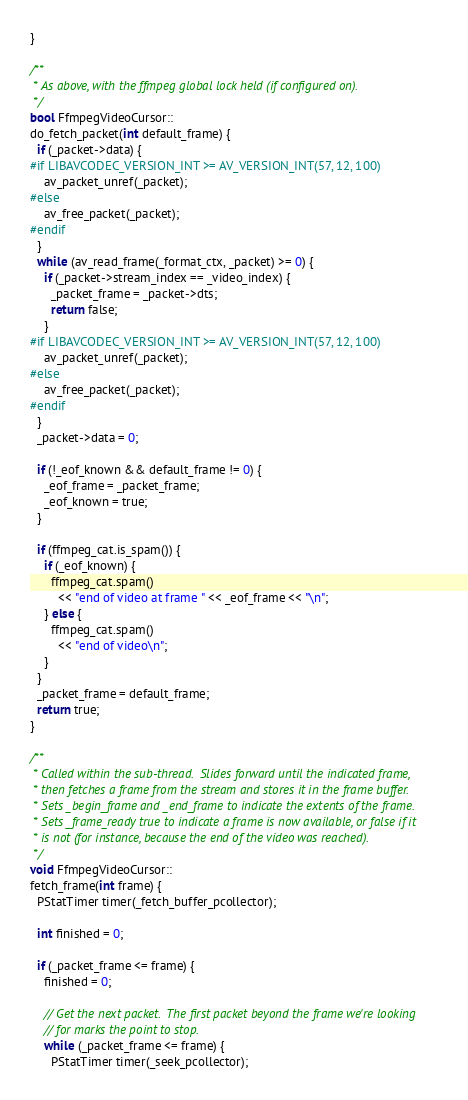Convert code to text. <code><loc_0><loc_0><loc_500><loc_500><_C++_>}

/**
 * As above, with the ffmpeg global lock held (if configured on).
 */
bool FfmpegVideoCursor::
do_fetch_packet(int default_frame) {
  if (_packet->data) {
#if LIBAVCODEC_VERSION_INT >= AV_VERSION_INT(57, 12, 100)
    av_packet_unref(_packet);
#else
    av_free_packet(_packet);
#endif
  }
  while (av_read_frame(_format_ctx, _packet) >= 0) {
    if (_packet->stream_index == _video_index) {
      _packet_frame = _packet->dts;
      return false;
    }
#if LIBAVCODEC_VERSION_INT >= AV_VERSION_INT(57, 12, 100)
    av_packet_unref(_packet);
#else
    av_free_packet(_packet);
#endif
  }
  _packet->data = 0;

  if (!_eof_known && default_frame != 0) {
    _eof_frame = _packet_frame;
    _eof_known = true;
  }

  if (ffmpeg_cat.is_spam()) {
    if (_eof_known) {
      ffmpeg_cat.spam()
        << "end of video at frame " << _eof_frame << "\n";
    } else {
      ffmpeg_cat.spam()
        << "end of video\n";
    }
  }
  _packet_frame = default_frame;
  return true;
}

/**
 * Called within the sub-thread.  Slides forward until the indicated frame,
 * then fetches a frame from the stream and stores it in the frame buffer.
 * Sets _begin_frame and _end_frame to indicate the extents of the frame.
 * Sets _frame_ready true to indicate a frame is now available, or false if it
 * is not (for instance, because the end of the video was reached).
 */
void FfmpegVideoCursor::
fetch_frame(int frame) {
  PStatTimer timer(_fetch_buffer_pcollector);

  int finished = 0;

  if (_packet_frame <= frame) {
    finished = 0;

    // Get the next packet.  The first packet beyond the frame we're looking
    // for marks the point to stop.
    while (_packet_frame <= frame) {
      PStatTimer timer(_seek_pcollector);
</code> 